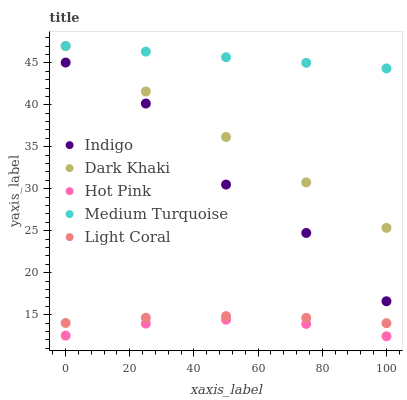Does Hot Pink have the minimum area under the curve?
Answer yes or no. Yes. Does Medium Turquoise have the maximum area under the curve?
Answer yes or no. Yes. Does Light Coral have the minimum area under the curve?
Answer yes or no. No. Does Light Coral have the maximum area under the curve?
Answer yes or no. No. Is Dark Khaki the smoothest?
Answer yes or no. Yes. Is Indigo the roughest?
Answer yes or no. Yes. Is Light Coral the smoothest?
Answer yes or no. No. Is Light Coral the roughest?
Answer yes or no. No. Does Hot Pink have the lowest value?
Answer yes or no. Yes. Does Light Coral have the lowest value?
Answer yes or no. No. Does Medium Turquoise have the highest value?
Answer yes or no. Yes. Does Light Coral have the highest value?
Answer yes or no. No. Is Hot Pink less than Light Coral?
Answer yes or no. Yes. Is Indigo greater than Light Coral?
Answer yes or no. Yes. Does Medium Turquoise intersect Dark Khaki?
Answer yes or no. Yes. Is Medium Turquoise less than Dark Khaki?
Answer yes or no. No. Is Medium Turquoise greater than Dark Khaki?
Answer yes or no. No. Does Hot Pink intersect Light Coral?
Answer yes or no. No. 